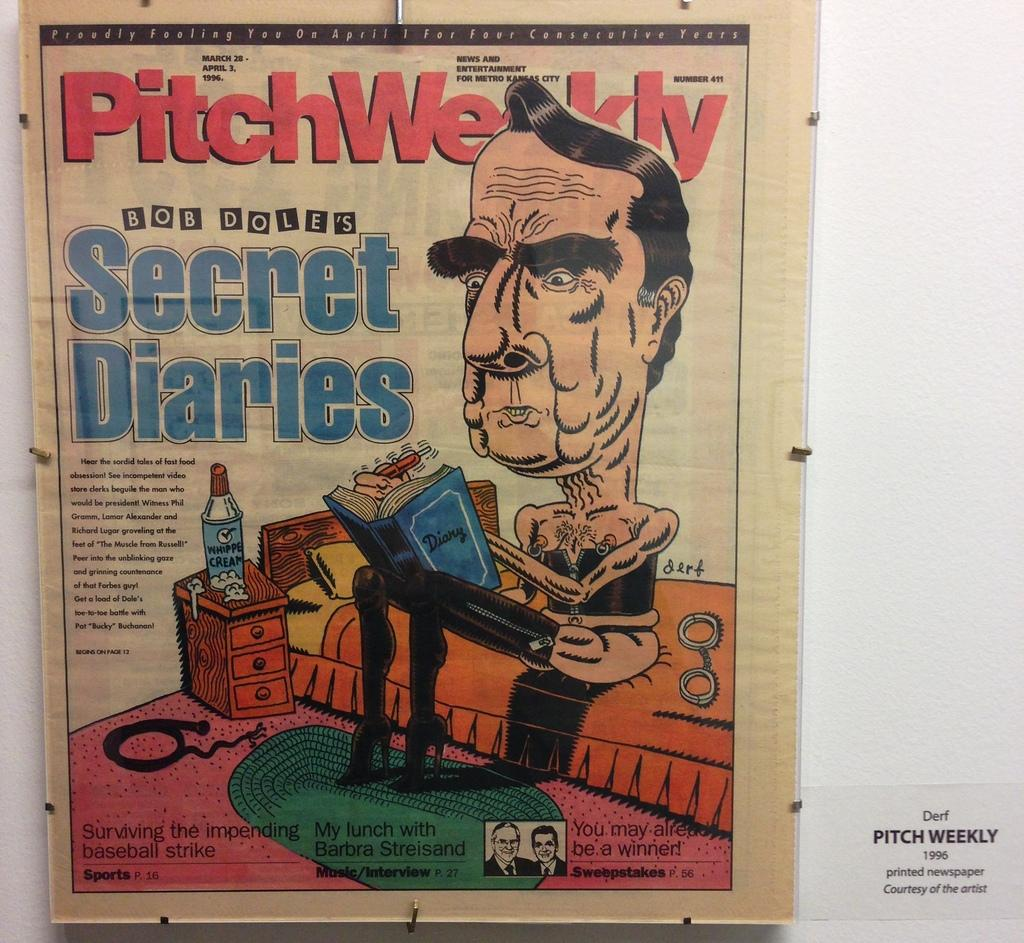<image>
Write a terse but informative summary of the picture. A cover of the magazine Pitch Weekly with a cartoon of a man in high heeled boots. 